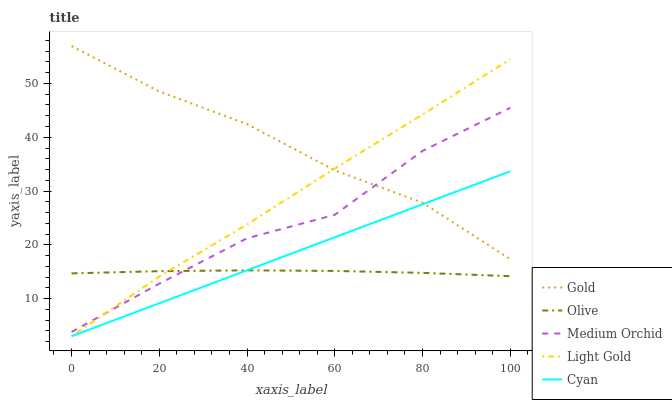Does Cyan have the minimum area under the curve?
Answer yes or no. No. Does Cyan have the maximum area under the curve?
Answer yes or no. No. Is Medium Orchid the smoothest?
Answer yes or no. No. Is Cyan the roughest?
Answer yes or no. No. Does Medium Orchid have the lowest value?
Answer yes or no. No. Does Cyan have the highest value?
Answer yes or no. No. Is Olive less than Gold?
Answer yes or no. Yes. Is Medium Orchid greater than Cyan?
Answer yes or no. Yes. Does Olive intersect Gold?
Answer yes or no. No. 